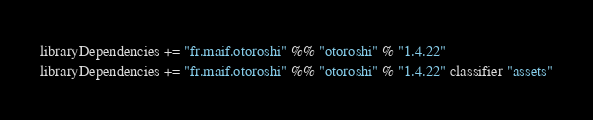Convert code to text. <code><loc_0><loc_0><loc_500><loc_500><_Scala_>
libraryDependencies += "fr.maif.otoroshi" %% "otoroshi" % "1.4.22"
libraryDependencies += "fr.maif.otoroshi" %% "otoroshi" % "1.4.22" classifier "assets"</code> 